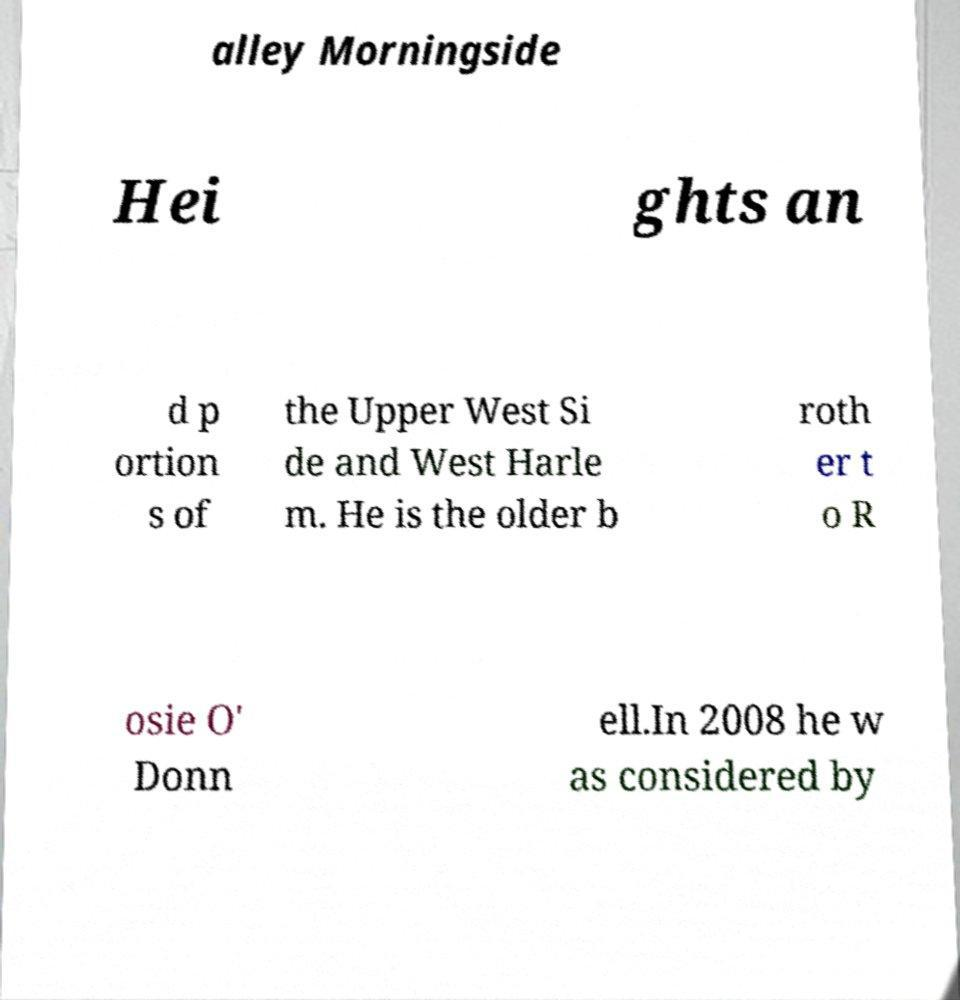Can you read and provide the text displayed in the image?This photo seems to have some interesting text. Can you extract and type it out for me? alley Morningside Hei ghts an d p ortion s of the Upper West Si de and West Harle m. He is the older b roth er t o R osie O' Donn ell.In 2008 he w as considered by 